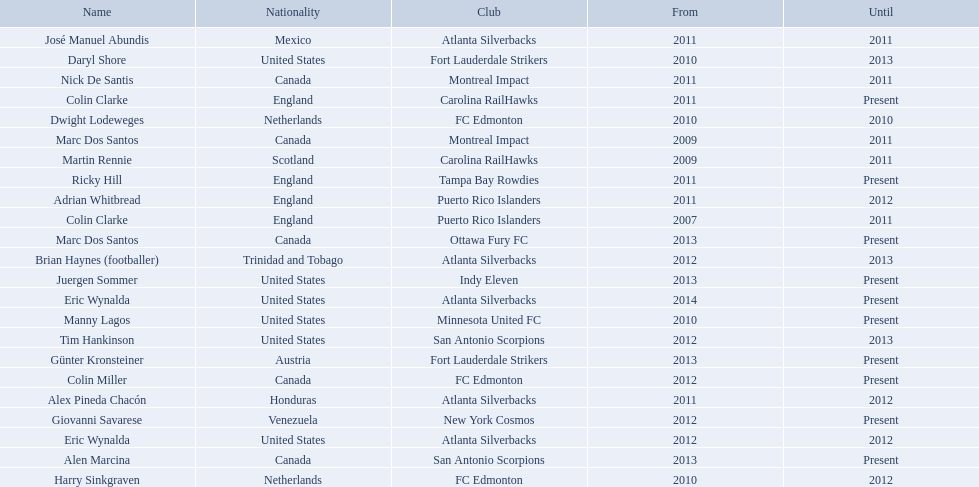What year did marc dos santos start as coach? 2009. Which other starting years correspond with this year? 2009. Who was the other coach with this starting year Martin Rennie. 